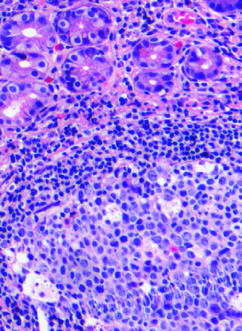s a distinct nuclear inclusion and multiple cytoplasmic inclusions characteristic of h. pylori gastritis?
Answer the question using a single word or phrase. No 